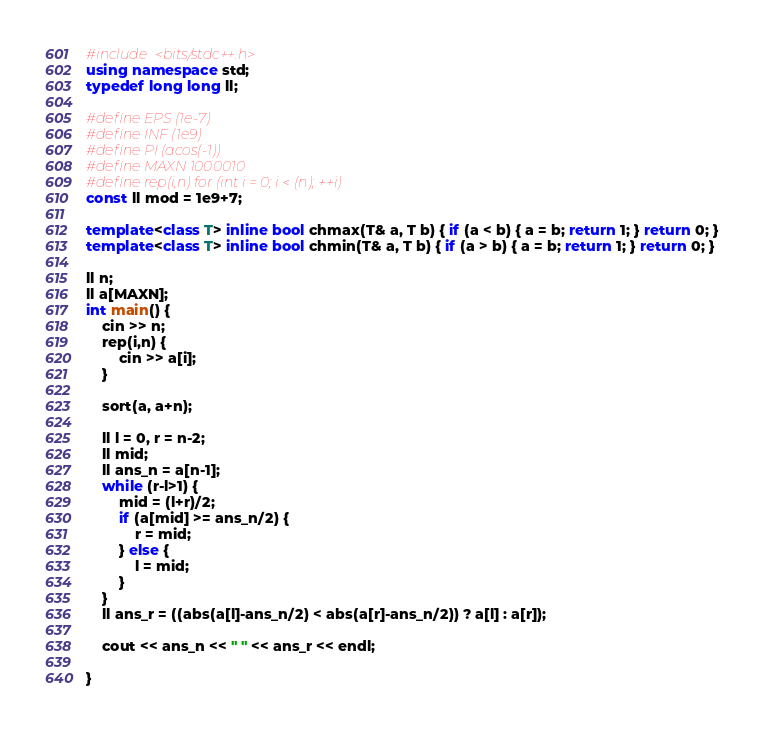<code> <loc_0><loc_0><loc_500><loc_500><_C++_>#include <bits/stdc++.h>
using namespace std;
typedef long long ll;

#define EPS (1e-7)
#define INF (1e9)
#define PI (acos(-1))
#define MAXN 1000010
#define rep(i,n) for (int i = 0; i < (n); ++i)
const ll mod = 1e9+7;

template<class T> inline bool chmax(T& a, T b) { if (a < b) { a = b; return 1; } return 0; }
template<class T> inline bool chmin(T& a, T b) { if (a > b) { a = b; return 1; } return 0; }

ll n;
ll a[MAXN];
int main() {
    cin >> n;
    rep(i,n) {
        cin >> a[i];
    }

    sort(a, a+n);

    ll l = 0, r = n-2;
    ll mid;
    ll ans_n = a[n-1];
    while (r-l>1) {
        mid = (l+r)/2;
        if (a[mid] >= ans_n/2) {
            r = mid;
        } else {
            l = mid;
        }
    }
    ll ans_r = ((abs(a[l]-ans_n/2) < abs(a[r]-ans_n/2)) ? a[l] : a[r]);

    cout << ans_n << " " << ans_r << endl;

}

</code> 